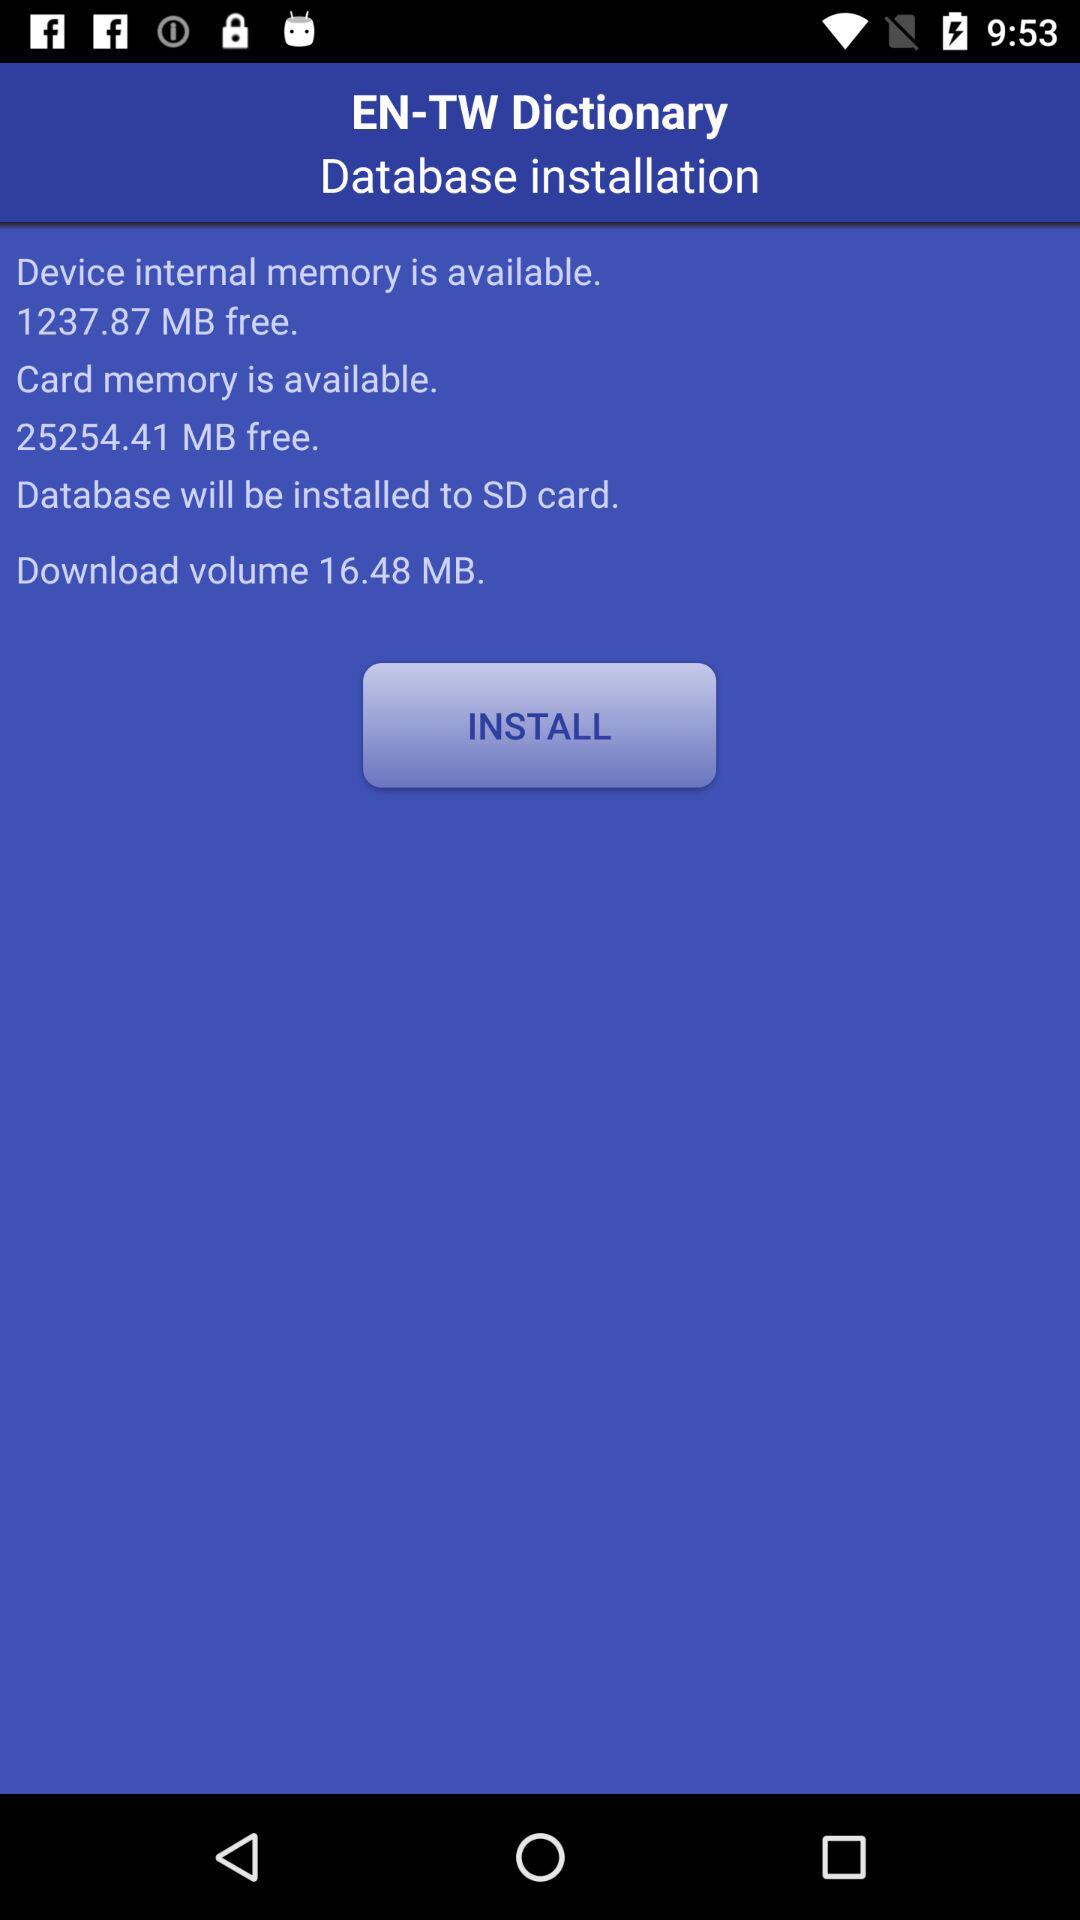How much device internal memory is available? The available internal memory is 1237.87 MB. 